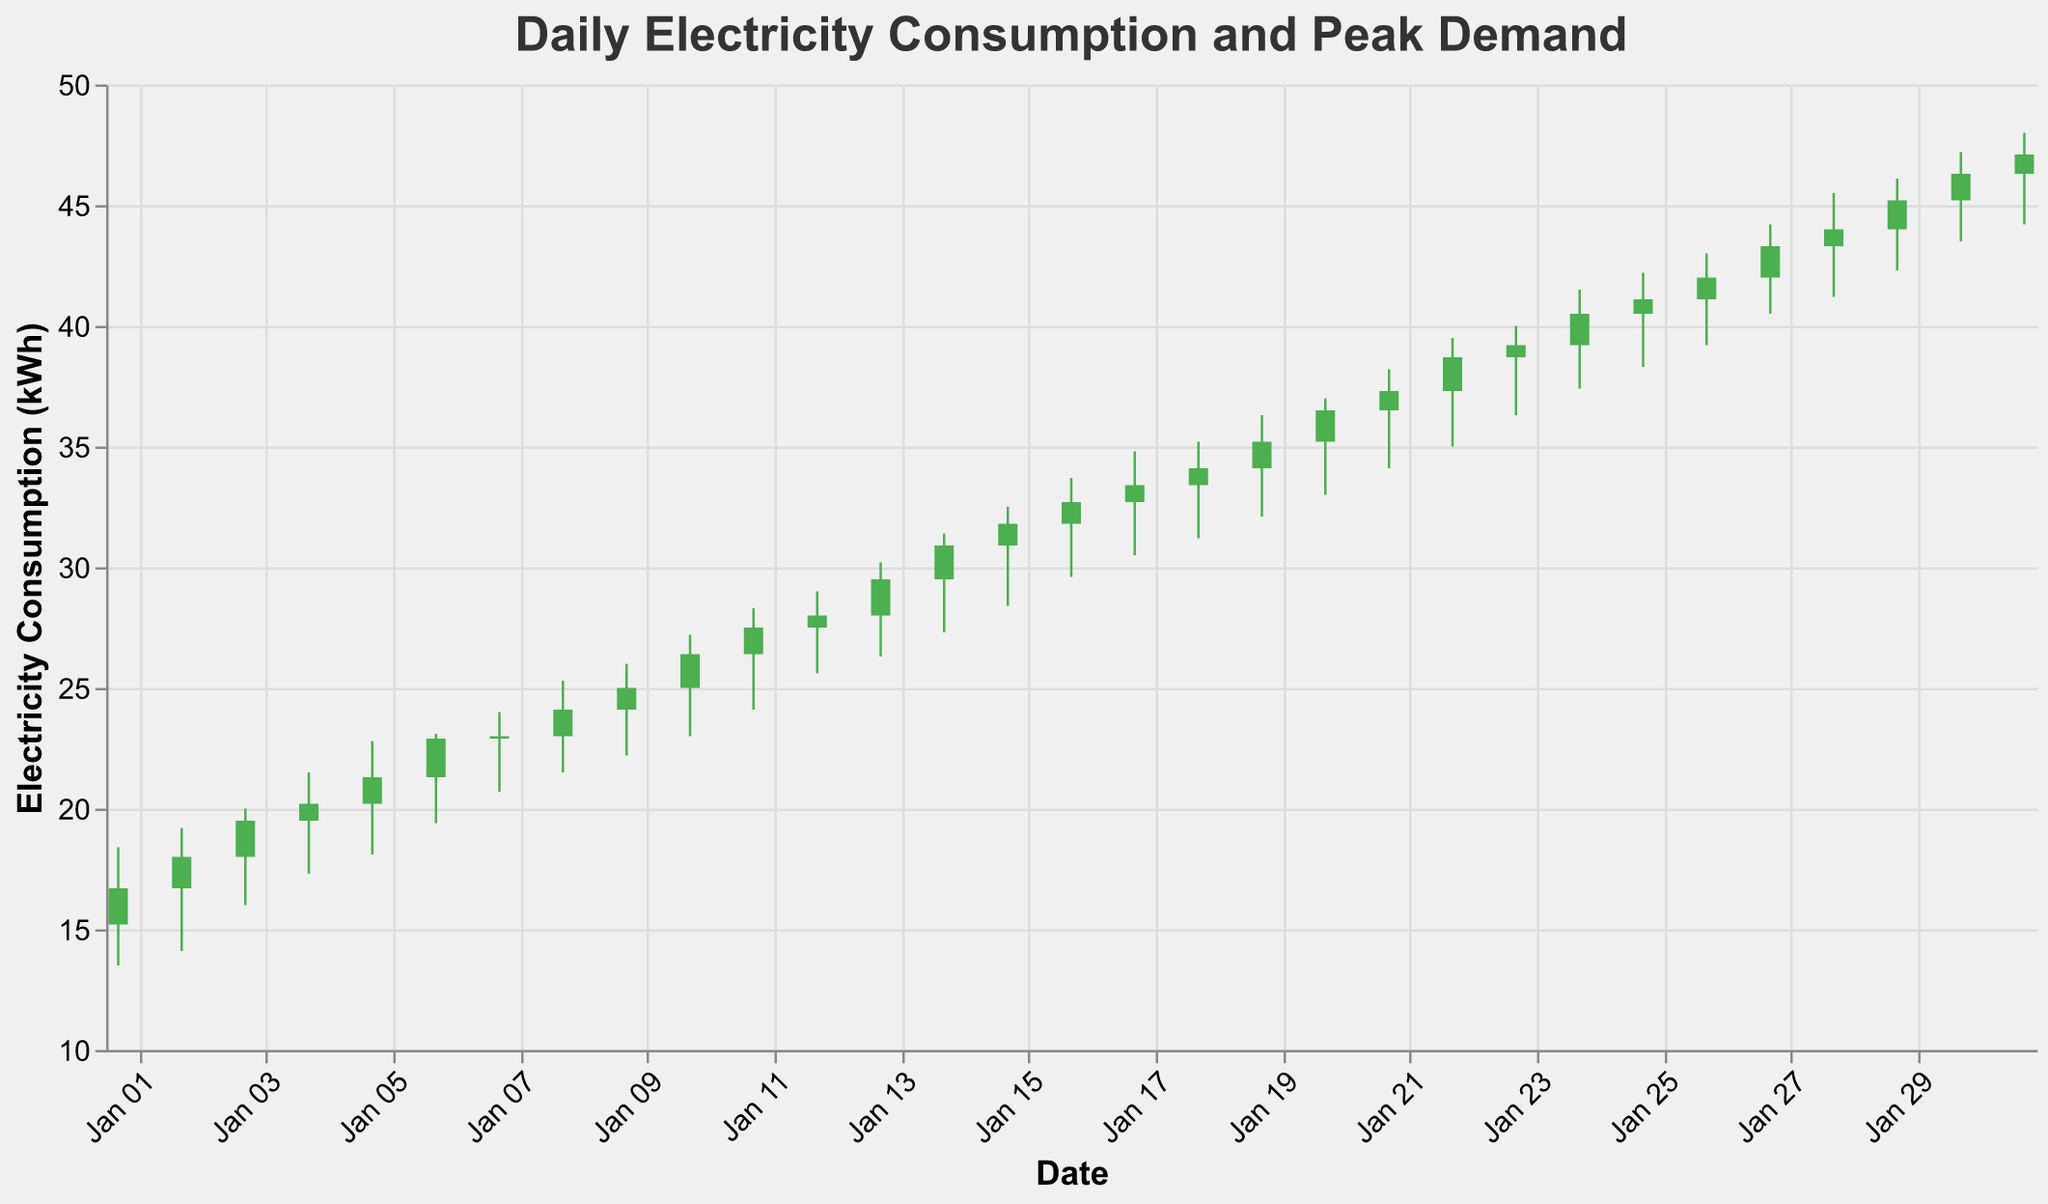What is the title of the figure? The title of the figure is usually found at the top and is designed to give a quick insight into what the figure is about. Here, it states the main subject "Daily Electricity Consumption and Peak Demand"
Answer: Daily Electricity Consumption and Peak Demand What do the colors green and red represent in the plot? The colors help to differentiate between the days when the electricity consumption increased (green) or decreased (red). Green bars are for days when the closing value is higher than the opening value, and red bars are for the opposite.
Answer: Green = Increase, Red = Decrease How many days had the highest peak demand above 30 kWh? To answer this, count the number of days where the "High" values are greater than 30 kWh. Look through the plot to see such instances.
Answer: 18 days Which day had the maximum consumption, and what was its value? This can be found by identifying the day with the highest "High" value in the chart. The plot shows that the highest peak demand occurs on 2023-01-31 with a value of 48.0 kWh.
Answer: January 31, 48.0 kWh What was the electricity consumption range on January 05, 2023? Check the data row for January 05 or locate this day on the plot. The range is determined by looking at the "Low" and "High" values.
Answer: 18.1 kWh to 22.8 kWh Is there a noticeable trend in electricity consumption? By visually analyzing the plot, you can determine if the overall trend is upward or downward. Here, the overall trend shows an increasing pattern as we move from January 1 to January 31.
Answer: Upward trend On which days did the closing value exactly match the high value? This requires checking the days where the "Close" value is equal to the "High" value. In the plot, check the height of the closing bar for each day.
Answer: No days What is the total increase in closing value from January 1 to January 31? To find this, compute the difference between the closing value on the last day and the first day of the month. Subtract the close value of January 01 (16.7) from January 31 (47.1).
Answer: 47.1 - 16.7 = 30.4 kWh Which day had the smallest range of electricity consumption? Identify the day where the difference between "High" and "Low" values is the smallest by checking each day's range.
Answer: January 07, range of 3.3 kWh (24.0 - 20.7) How does the trend between January 14 and January 17 compare to the trend between January 24 and January 27? To compare trends, look at the change in closing values across these intervals. From Jan 14 to Jan 17, the trend is increasing from 30.9 to 33.4. From Jan 24 to Jan 27, it decreases from 41.1 to 43.3.
Answer: Jan 14-17: Increasing; Jan 24-27: Increasing 